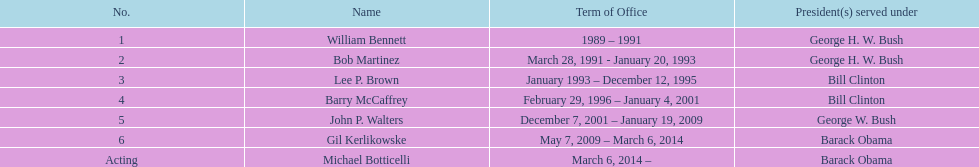What were the number of directors that stayed in office more than three years? 3. 